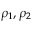Convert formula to latex. <formula><loc_0><loc_0><loc_500><loc_500>\rho _ { 1 } , \rho _ { 2 }</formula> 